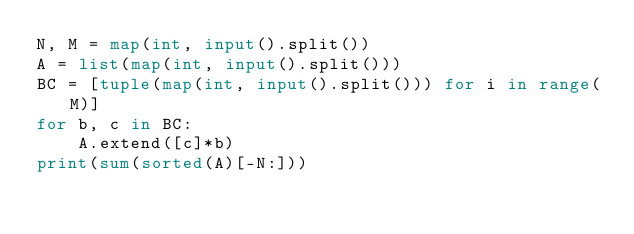<code> <loc_0><loc_0><loc_500><loc_500><_Python_>N, M = map(int, input().split())
A = list(map(int, input().split()))
BC = [tuple(map(int, input().split())) for i in range(M)]
for b, c in BC:
    A.extend([c]*b)
print(sum(sorted(A)[-N:]))</code> 